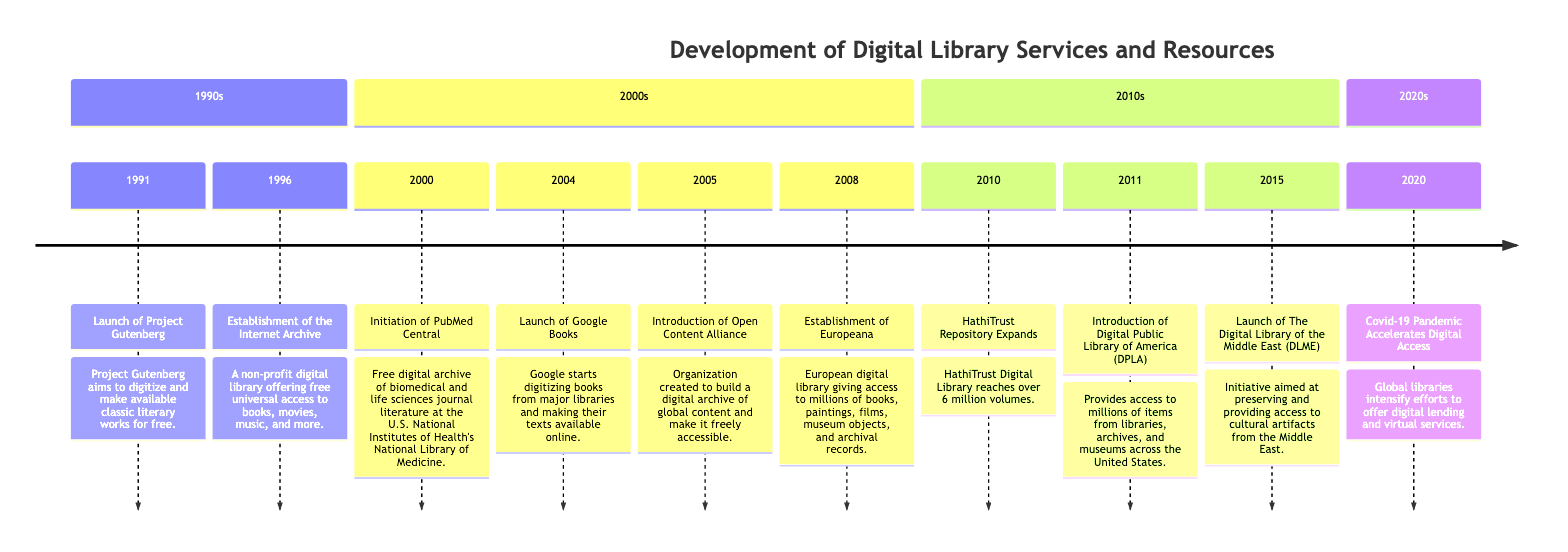What event started in 1991? The diagram indicates that the event which started in 1991 is the "Launch of Project Gutenberg." This is clearly stated under the date 1991.
Answer: Launch of Project Gutenberg How many volumes did HathiTrust reach in 2010? Referring to the timeline for the year 2010, it states that the HathiTrust Repository reached "over 6 million volumes." This figure is highlighted for that specific year.
Answer: Over 6 million volumes What non-profit digital library was established in 1996? In examining the timeline, the event listed for 1996 is the "Establishment of the Internet Archive," which is characterized as a non-profit digital library. This is the event associated with that year.
Answer: Establishment of the Internet Archive Which two initiatives were launched in 2005 and 2008 respectively? Upon inspecting the timeline, in 2005, the "Introduction of Open Content Alliance" was launched, and in 2008, "Establishment of Europeana" took place. By identifying these years and their associated events, we can answer the question about both initiatives.
Answer: Introduction of Open Content Alliance and Establishment of Europeana What significant impact did the Covid-19 pandemic have on libraries in 2020? The timeline notes that the "Covid-19 Pandemic Accelerates Digital Access" in 2020, indicating that libraries intensified efforts for digital lending and virtual services. This connection between the event and its impact is shown in the diagram.
Answer: Accelerates Digital Access What digital service was introduced in 2011? The timeline indicates that in the year 2011, the "Introduction of Digital Public Library of America (DPLA)" occurred. This is specifically stated as the event for that year.
Answer: Introduction of Digital Public Library of America (DPLA) How many major dates are represented in the timeline? By counting the listed events in the timeline, we see there are 10 distinct dates spanning from 1991 to 2020. This count is derived from simply enumerating the separate entries in the timeline.
Answer: 10 Which digital library focuses on cultural artifacts from the Middle East? From the timeline, the event from 2015 states the "Launch of The Digital Library of the Middle East (DLME)," which specifically aims at preserving and providing access to cultural artifacts. This designation is clear in the description.
Answer: The Digital Library of the Middle East (DLME) What digital archive was established by the U.S. National Institutes of Health in 2000? Observing the entry from the year 2000, the timeline describes the "Initiation of PubMed Central," which is the digital archive launched by the U.S. National Institutes of Health. This establishes the answer.
Answer: Initiation of PubMed Central 